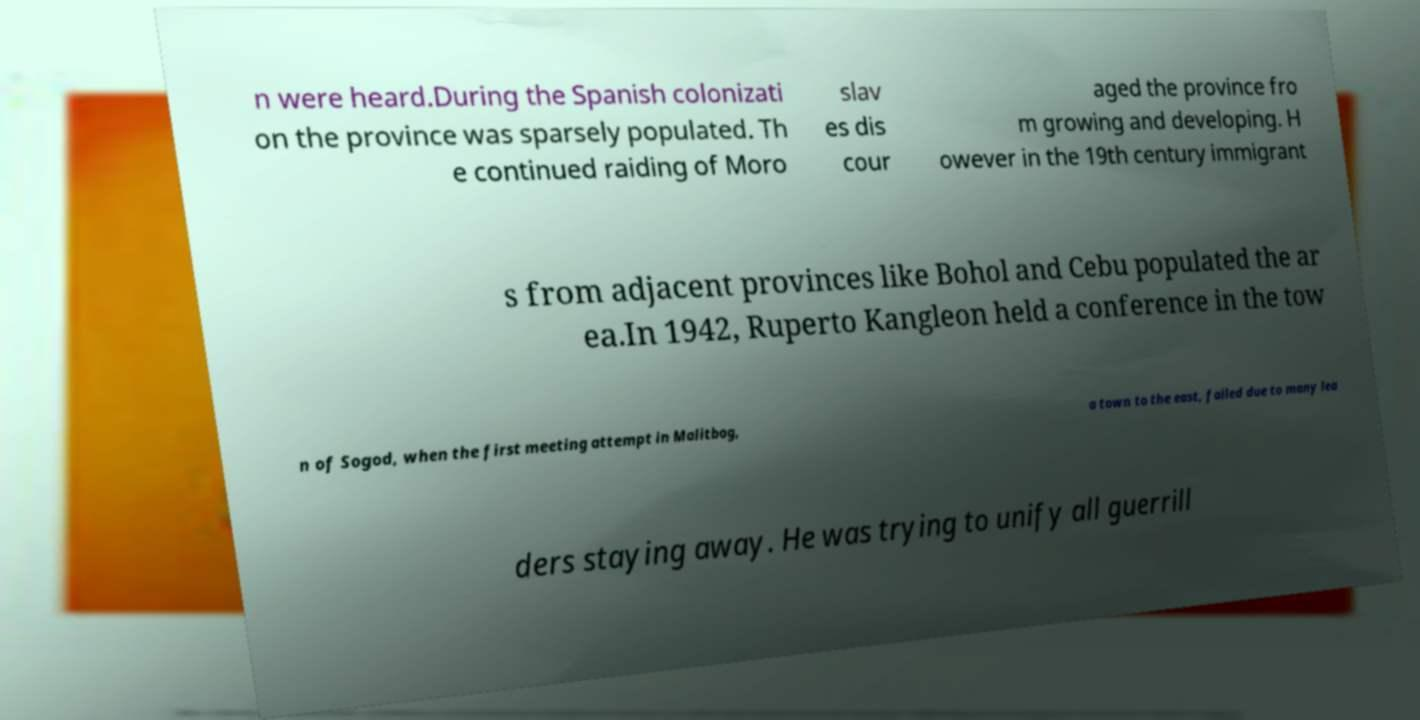For documentation purposes, I need the text within this image transcribed. Could you provide that? n were heard.During the Spanish colonizati on the province was sparsely populated. Th e continued raiding of Moro slav es dis cour aged the province fro m growing and developing. H owever in the 19th century immigrant s from adjacent provinces like Bohol and Cebu populated the ar ea.In 1942, Ruperto Kangleon held a conference in the tow n of Sogod, when the first meeting attempt in Malitbog, a town to the east, failed due to many lea ders staying away. He was trying to unify all guerrill 